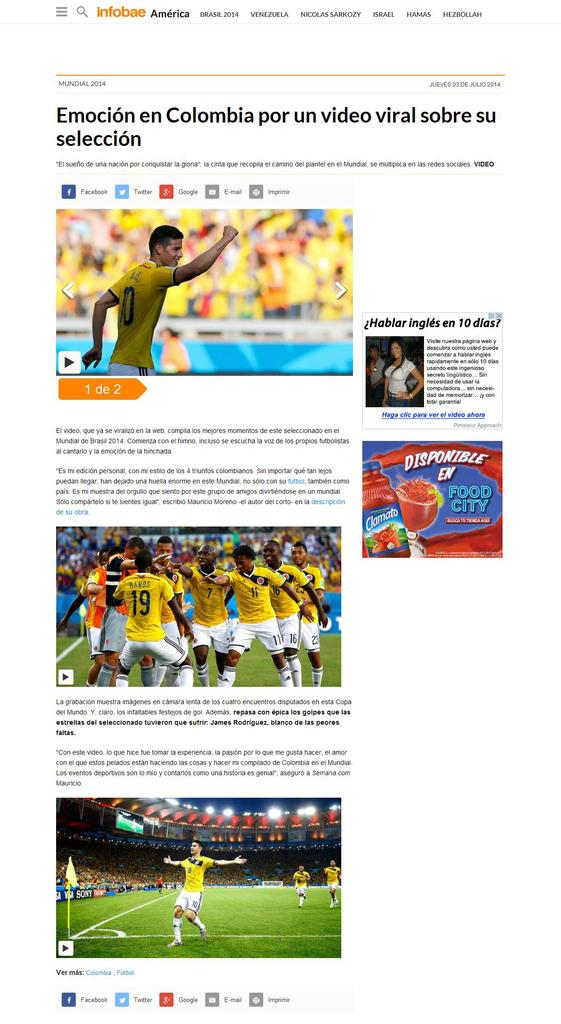<image>
Summarize the visual content of the image. an article about soccer with emocion written on it 